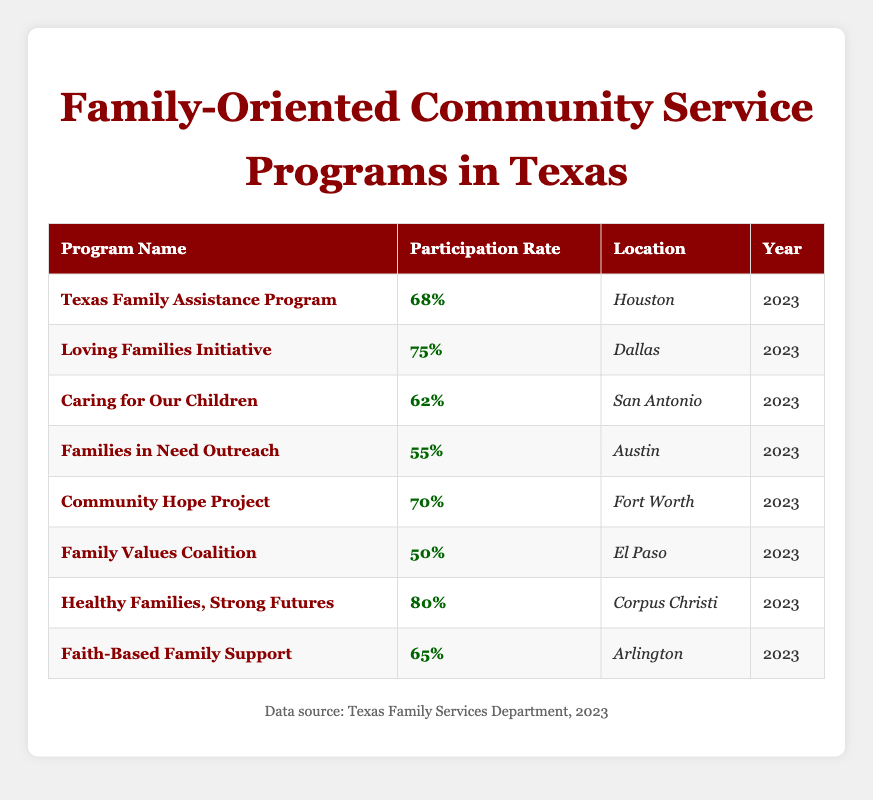What is the participation rate for the Healthy Families, Strong Futures program? The table lists the participation rate for each program. For the Healthy Families, Strong Futures program, the participation rate is clearly stated as 80%.
Answer: 80% Which program has the highest participation rate? By comparing the participation rates of all the programs listed in the table, the one with the highest rate is the Healthy Families, Strong Futures program, which has a participation rate of 80%.
Answer: Healthy Families, Strong Futures How many programs have a participation rate of 65% or higher? The table shows the participation rates for each program. The programs with rates of 65% or higher are the Loving Families Initiative (75%), Community Hope Project (70%), Healthy Families, Strong Futures (80%), and Faith-Based Family Support (65%). This totals four programs.
Answer: 4 What is the average participation rate of all the programs listed? To find the average participation rate, I will first sum the participation rates: 68 + 75 + 62 + 55 + 70 + 50 + 80 + 65 = 625. Then, I divide by the number of programs (8), which gives 625/8 = 78.125. This rounds down to an average participation rate of approximately 78% for all programs.
Answer: 78% Are there any programs with a participation rate lower than 60%? By examining the table, I can see that the Families in Need Outreach program has a participation rate of 55%, and the Family Values Coalition has a rate of 50%. Hence, there are indeed programs with rates lower than 60%.
Answer: Yes What is the difference in participation rates between the Loving Families Initiative and the Family Values Coalition? The participation rate for the Loving Families Initiative is 75%, and for the Family Values Coalition, it is 50%. To find the difference, I subtract: 75 - 50 = 25. So, the difference in participation rates is 25%.
Answer: 25% In which locations are the programs with participation rates below 60% found? The Families in Need Outreach program with a participation rate of 55% is located in Austin, and the Family Values Coalition with a 50% rate is in El Paso. Thus, these programs with rates below 60% are found in Austin and El Paso.
Answer: Austin and El Paso What percentage of programs have their locations in major cities (Houston, Dallas, San Antonio, Austin, Fort Worth)? From the table, the programs located in major cities are Texas Family Assistance Program (Houston), Loving Families Initiative (Dallas), Caring for Our Children (San Antonio), and Families in Need Outreach (Austin). There are 5 programs in major cities out of a total of 8 programs. The percentage is calculated as (5/8) * 100 = 62.5%.
Answer: 62.5% 